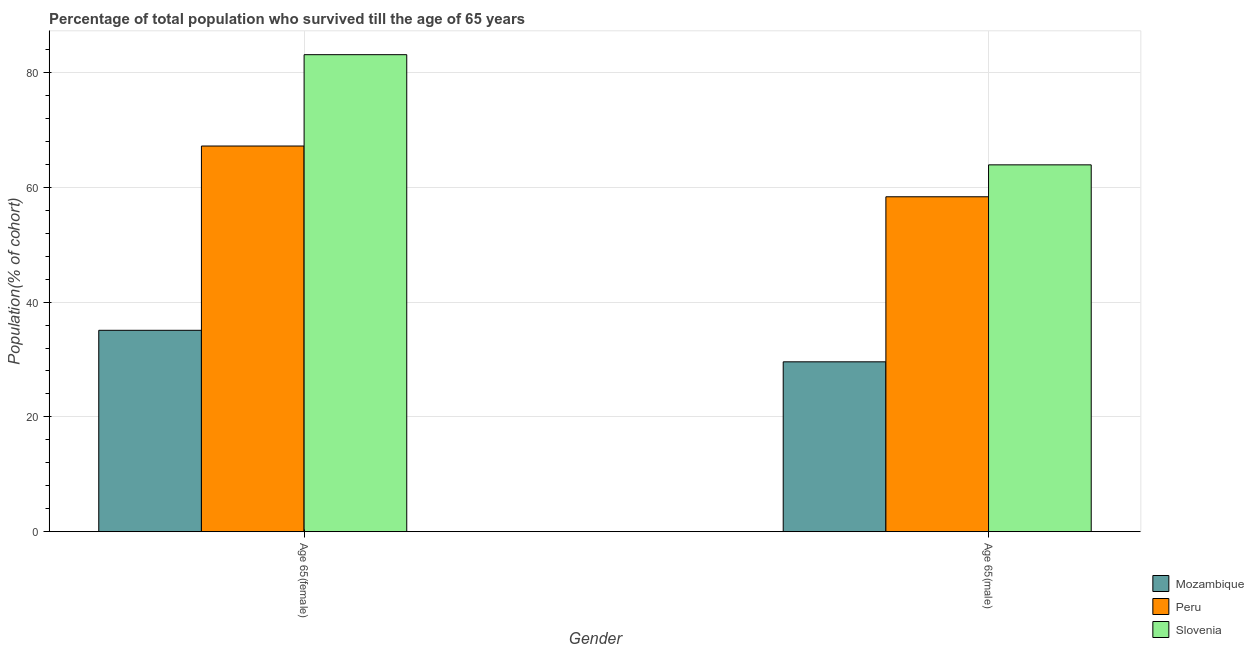Are the number of bars per tick equal to the number of legend labels?
Offer a terse response. Yes. How many bars are there on the 2nd tick from the left?
Keep it short and to the point. 3. How many bars are there on the 2nd tick from the right?
Provide a succinct answer. 3. What is the label of the 1st group of bars from the left?
Provide a short and direct response. Age 65(female). What is the percentage of female population who survived till age of 65 in Peru?
Your answer should be compact. 67.2. Across all countries, what is the maximum percentage of male population who survived till age of 65?
Give a very brief answer. 63.92. Across all countries, what is the minimum percentage of female population who survived till age of 65?
Provide a short and direct response. 35.09. In which country was the percentage of male population who survived till age of 65 maximum?
Your answer should be compact. Slovenia. In which country was the percentage of female population who survived till age of 65 minimum?
Offer a very short reply. Mozambique. What is the total percentage of male population who survived till age of 65 in the graph?
Your answer should be compact. 151.87. What is the difference between the percentage of male population who survived till age of 65 in Slovenia and that in Peru?
Your response must be concise. 5.56. What is the difference between the percentage of male population who survived till age of 65 in Mozambique and the percentage of female population who survived till age of 65 in Slovenia?
Keep it short and to the point. -53.51. What is the average percentage of male population who survived till age of 65 per country?
Make the answer very short. 50.62. What is the difference between the percentage of male population who survived till age of 65 and percentage of female population who survived till age of 65 in Peru?
Your answer should be very brief. -8.84. In how many countries, is the percentage of male population who survived till age of 65 greater than 36 %?
Your answer should be very brief. 2. What is the ratio of the percentage of male population who survived till age of 65 in Peru to that in Mozambique?
Offer a very short reply. 1.97. In how many countries, is the percentage of male population who survived till age of 65 greater than the average percentage of male population who survived till age of 65 taken over all countries?
Provide a short and direct response. 2. What does the 3rd bar from the left in Age 65(female) represents?
Make the answer very short. Slovenia. What does the 3rd bar from the right in Age 65(male) represents?
Keep it short and to the point. Mozambique. Are all the bars in the graph horizontal?
Offer a very short reply. No. How many countries are there in the graph?
Make the answer very short. 3. Are the values on the major ticks of Y-axis written in scientific E-notation?
Make the answer very short. No. Does the graph contain grids?
Your response must be concise. Yes. Where does the legend appear in the graph?
Offer a very short reply. Bottom right. How many legend labels are there?
Offer a terse response. 3. What is the title of the graph?
Keep it short and to the point. Percentage of total population who survived till the age of 65 years. Does "Bulgaria" appear as one of the legend labels in the graph?
Provide a succinct answer. No. What is the label or title of the Y-axis?
Provide a succinct answer. Population(% of cohort). What is the Population(% of cohort) of Mozambique in Age 65(female)?
Provide a succinct answer. 35.09. What is the Population(% of cohort) in Peru in Age 65(female)?
Your answer should be compact. 67.2. What is the Population(% of cohort) in Slovenia in Age 65(female)?
Your response must be concise. 83.11. What is the Population(% of cohort) in Mozambique in Age 65(male)?
Your response must be concise. 29.6. What is the Population(% of cohort) of Peru in Age 65(male)?
Your answer should be very brief. 58.35. What is the Population(% of cohort) of Slovenia in Age 65(male)?
Your response must be concise. 63.92. Across all Gender, what is the maximum Population(% of cohort) in Mozambique?
Ensure brevity in your answer.  35.09. Across all Gender, what is the maximum Population(% of cohort) of Peru?
Your response must be concise. 67.2. Across all Gender, what is the maximum Population(% of cohort) in Slovenia?
Make the answer very short. 83.11. Across all Gender, what is the minimum Population(% of cohort) in Mozambique?
Make the answer very short. 29.6. Across all Gender, what is the minimum Population(% of cohort) in Peru?
Your answer should be very brief. 58.35. Across all Gender, what is the minimum Population(% of cohort) of Slovenia?
Offer a terse response. 63.92. What is the total Population(% of cohort) in Mozambique in the graph?
Offer a very short reply. 64.69. What is the total Population(% of cohort) of Peru in the graph?
Ensure brevity in your answer.  125.55. What is the total Population(% of cohort) in Slovenia in the graph?
Ensure brevity in your answer.  147.02. What is the difference between the Population(% of cohort) in Mozambique in Age 65(female) and that in Age 65(male)?
Provide a succinct answer. 5.49. What is the difference between the Population(% of cohort) in Peru in Age 65(female) and that in Age 65(male)?
Give a very brief answer. 8.84. What is the difference between the Population(% of cohort) in Slovenia in Age 65(female) and that in Age 65(male)?
Your response must be concise. 19.19. What is the difference between the Population(% of cohort) of Mozambique in Age 65(female) and the Population(% of cohort) of Peru in Age 65(male)?
Your answer should be compact. -23.26. What is the difference between the Population(% of cohort) in Mozambique in Age 65(female) and the Population(% of cohort) in Slovenia in Age 65(male)?
Offer a very short reply. -28.83. What is the difference between the Population(% of cohort) in Peru in Age 65(female) and the Population(% of cohort) in Slovenia in Age 65(male)?
Ensure brevity in your answer.  3.28. What is the average Population(% of cohort) in Mozambique per Gender?
Your answer should be very brief. 32.34. What is the average Population(% of cohort) of Peru per Gender?
Offer a terse response. 62.77. What is the average Population(% of cohort) in Slovenia per Gender?
Make the answer very short. 73.51. What is the difference between the Population(% of cohort) in Mozambique and Population(% of cohort) in Peru in Age 65(female)?
Give a very brief answer. -32.11. What is the difference between the Population(% of cohort) of Mozambique and Population(% of cohort) of Slovenia in Age 65(female)?
Ensure brevity in your answer.  -48.02. What is the difference between the Population(% of cohort) of Peru and Population(% of cohort) of Slovenia in Age 65(female)?
Give a very brief answer. -15.91. What is the difference between the Population(% of cohort) in Mozambique and Population(% of cohort) in Peru in Age 65(male)?
Provide a succinct answer. -28.76. What is the difference between the Population(% of cohort) of Mozambique and Population(% of cohort) of Slovenia in Age 65(male)?
Your answer should be compact. -34.32. What is the difference between the Population(% of cohort) in Peru and Population(% of cohort) in Slovenia in Age 65(male)?
Provide a succinct answer. -5.56. What is the ratio of the Population(% of cohort) of Mozambique in Age 65(female) to that in Age 65(male)?
Provide a short and direct response. 1.19. What is the ratio of the Population(% of cohort) in Peru in Age 65(female) to that in Age 65(male)?
Provide a short and direct response. 1.15. What is the ratio of the Population(% of cohort) in Slovenia in Age 65(female) to that in Age 65(male)?
Offer a terse response. 1.3. What is the difference between the highest and the second highest Population(% of cohort) in Mozambique?
Your answer should be very brief. 5.49. What is the difference between the highest and the second highest Population(% of cohort) in Peru?
Your response must be concise. 8.84. What is the difference between the highest and the second highest Population(% of cohort) in Slovenia?
Provide a short and direct response. 19.19. What is the difference between the highest and the lowest Population(% of cohort) in Mozambique?
Your answer should be very brief. 5.49. What is the difference between the highest and the lowest Population(% of cohort) in Peru?
Your response must be concise. 8.84. What is the difference between the highest and the lowest Population(% of cohort) of Slovenia?
Your answer should be compact. 19.19. 